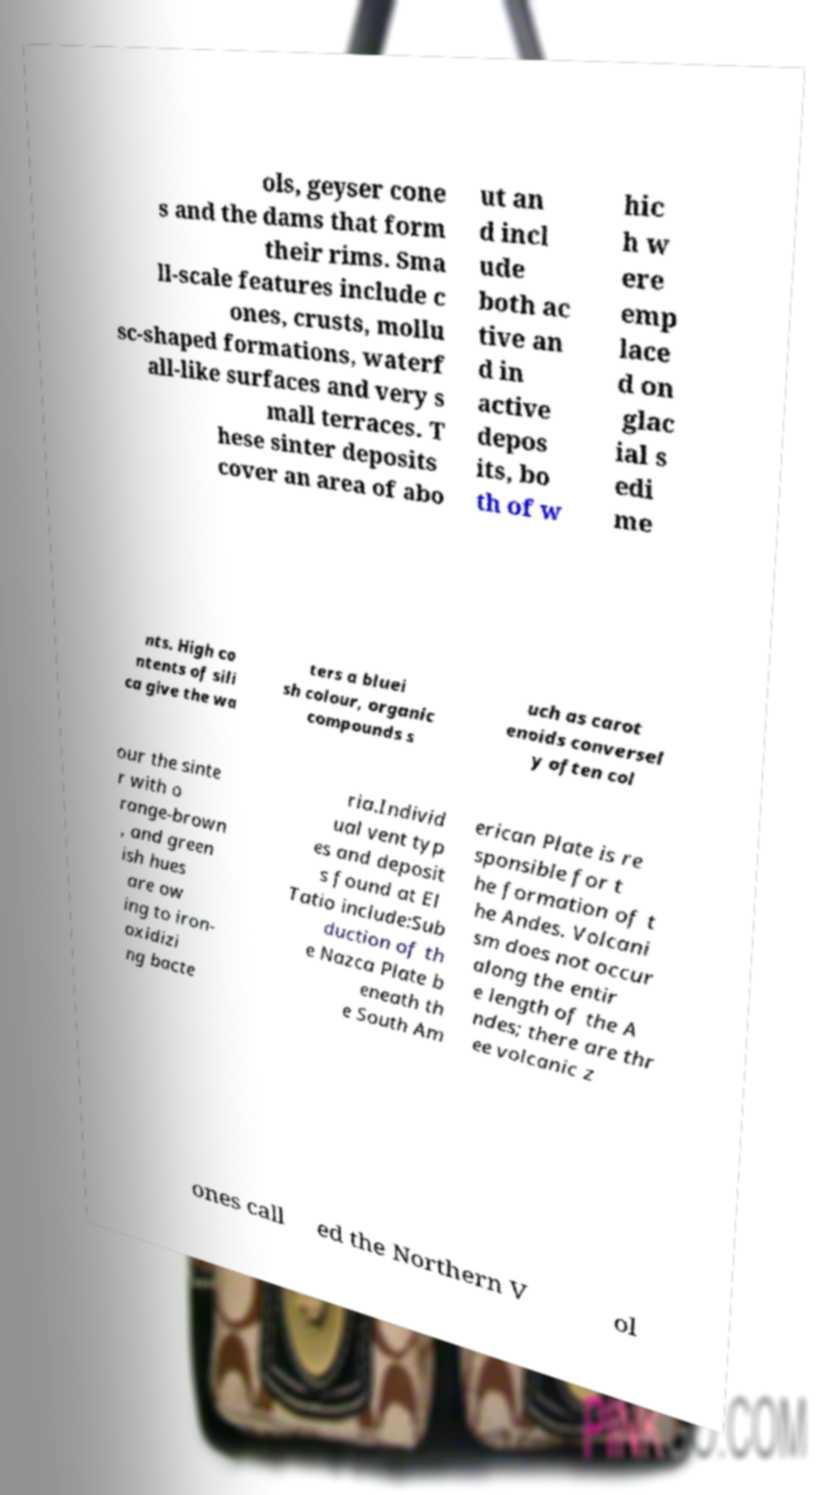I need the written content from this picture converted into text. Can you do that? ols, geyser cone s and the dams that form their rims. Sma ll-scale features include c ones, crusts, mollu sc-shaped formations, waterf all-like surfaces and very s mall terraces. T hese sinter deposits cover an area of abo ut an d incl ude both ac tive an d in active depos its, bo th of w hic h w ere emp lace d on glac ial s edi me nts. High co ntents of sili ca give the wa ters a bluei sh colour, organic compounds s uch as carot enoids conversel y often col our the sinte r with o range-brown , and green ish hues are ow ing to iron- oxidizi ng bacte ria.Individ ual vent typ es and deposit s found at El Tatio include:Sub duction of th e Nazca Plate b eneath th e South Am erican Plate is re sponsible for t he formation of t he Andes. Volcani sm does not occur along the entir e length of the A ndes; there are thr ee volcanic z ones call ed the Northern V ol 